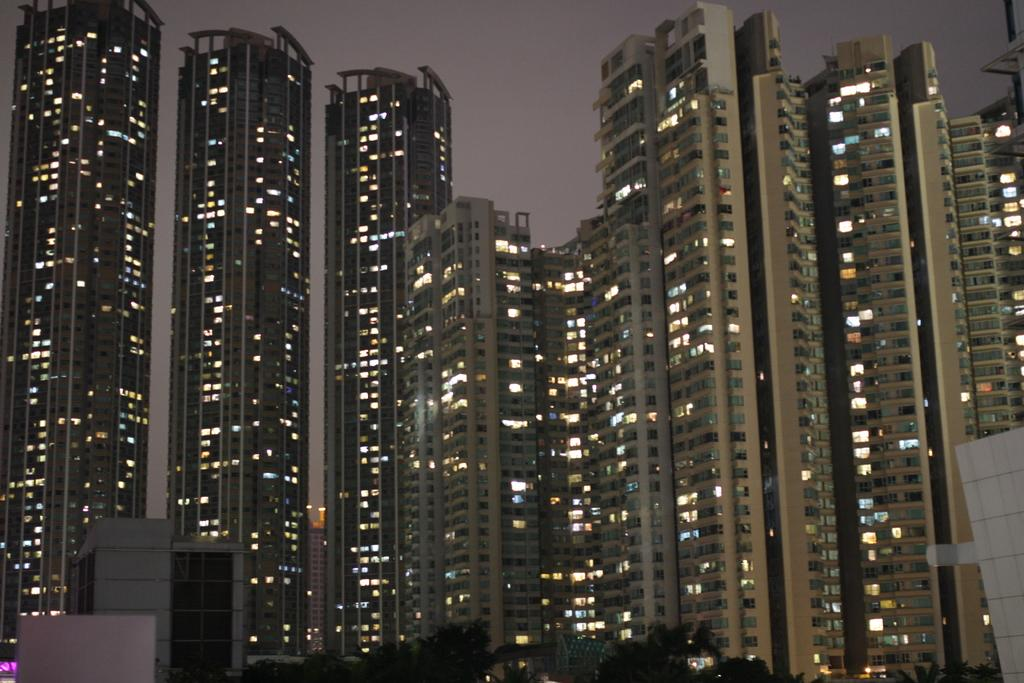What type of structures can be seen in the image? There are buildings in the image. What other natural elements are present in the image? There are trees in the image. What part of the natural environment is visible in the image? The sky is visible in the image. What type of wood is the maid using to clean the windows in the image? There is no maid or windows present in the image, so it is not possible to determine what type of wood might be used for cleaning. 